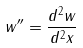Convert formula to latex. <formula><loc_0><loc_0><loc_500><loc_500>w ^ { \prime \prime } = \frac { d ^ { 2 } w } { d ^ { 2 } x }</formula> 